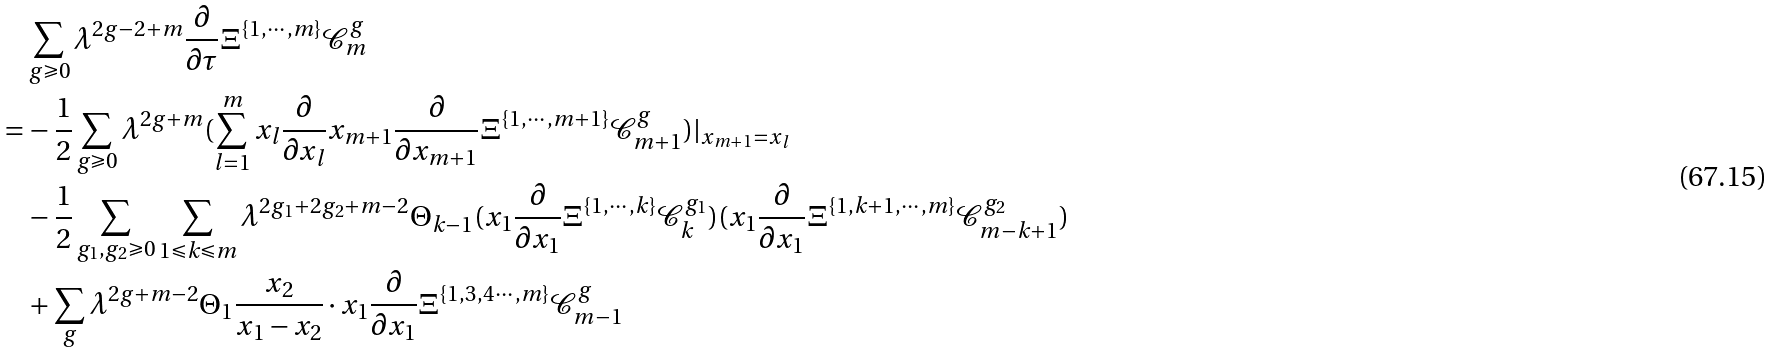Convert formula to latex. <formula><loc_0><loc_0><loc_500><loc_500>& \sum _ { g \geqslant 0 } \lambda ^ { 2 g - 2 + m } \frac { \partial } { \partial \tau } \Xi ^ { \{ 1 , \cdots , m \} } \mathcal { C } _ { m } ^ { g } \\ = & - \frac { 1 } { 2 } \sum _ { g \geqslant 0 } \lambda ^ { 2 g + m } ( \sum _ { l = 1 } ^ { m } x _ { l } \frac { \partial } { \partial x _ { l } } x _ { m + 1 } \frac { \partial } { \partial x _ { m + 1 } } \Xi ^ { \{ 1 , \cdots , m + 1 \} } \mathcal { C } _ { m + 1 } ^ { g } ) | _ { x _ { m + 1 } = x _ { l } } \\ & - \frac { 1 } { 2 } \sum _ { g _ { 1 } , g _ { 2 } \geqslant 0 } \sum _ { 1 \leqslant k \leqslant m } \lambda ^ { 2 g _ { 1 } + 2 g _ { 2 } + m - 2 } \Theta _ { k - 1 } ( x _ { 1 } \frac { \partial } { \partial x _ { 1 } } \Xi ^ { \{ 1 , \cdots , k \} } \mathcal { C } _ { k } ^ { g _ { 1 } } ) ( x _ { 1 } \frac { \partial } { \partial x _ { 1 } } \Xi ^ { \{ 1 , k + 1 , \cdots , m \} } \mathcal { C } _ { m - k + 1 } ^ { g _ { 2 } } ) \\ & + \sum _ { g } \lambda ^ { 2 g + m - 2 } \Theta _ { 1 } \frac { x _ { 2 } } { x _ { 1 } - x _ { 2 } } \cdot x _ { 1 } \frac { \partial } { \partial x _ { 1 } } \Xi ^ { \{ 1 , 3 , 4 \cdots , m \} } \mathcal { C } _ { m - 1 } ^ { g }</formula> 